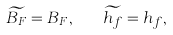Convert formula to latex. <formula><loc_0><loc_0><loc_500><loc_500>\widetilde { B _ { F } } = B _ { F } , \quad \widetilde { h _ { f } } = h _ { f } ,</formula> 